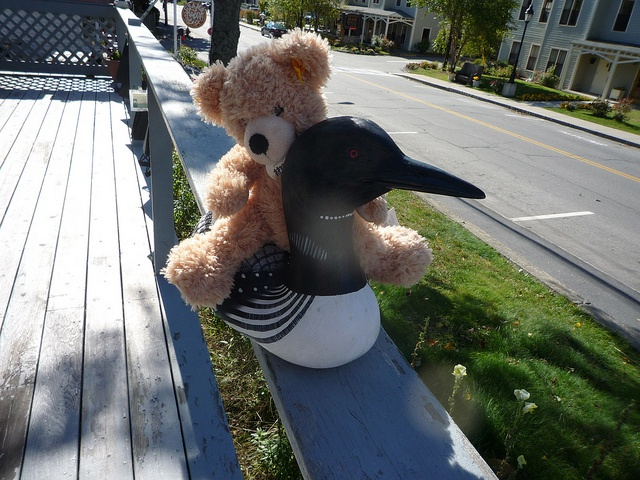Describe the objects in this image and their specific colors. I can see a teddy bear in black, gray, maroon, and ivory tones in this image. 